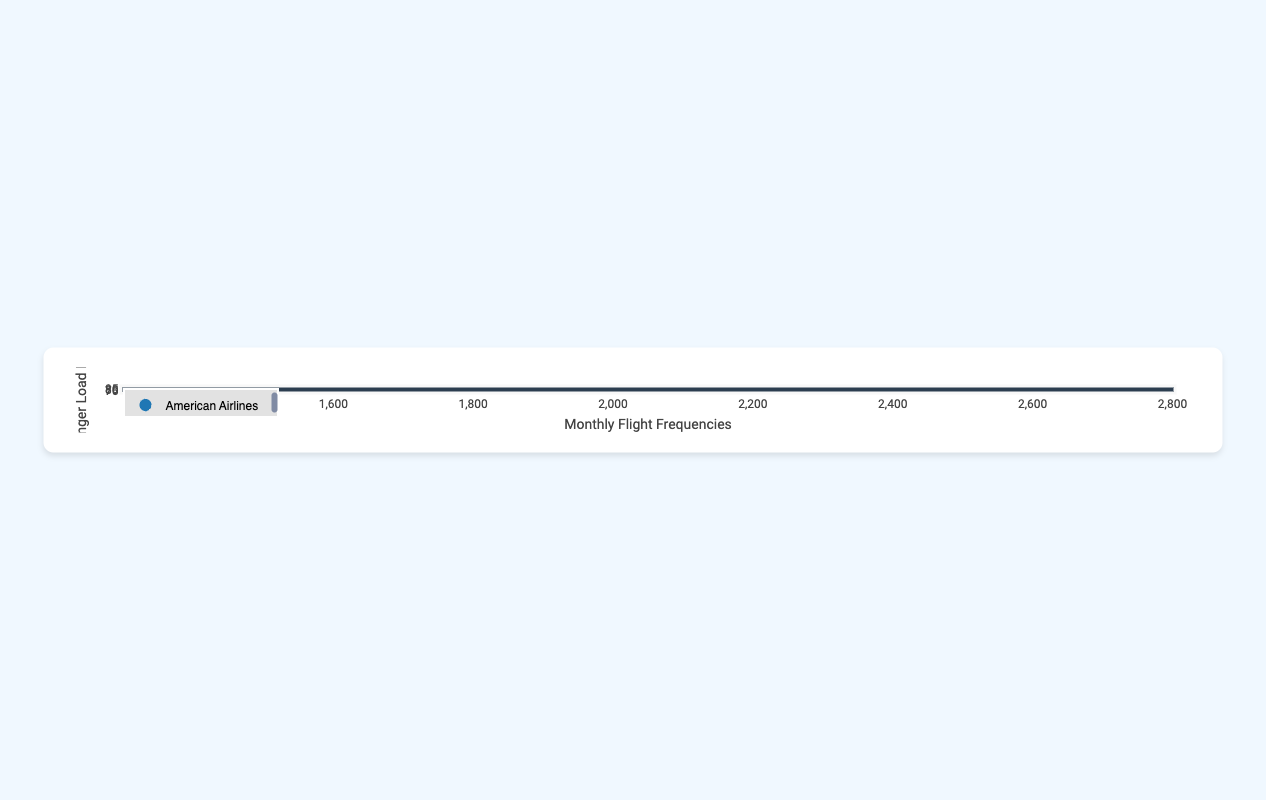What's the highest passenger load factor for January? The highest passenger load factor for January can be found by looking at the y-axis values for all data points labeled "January." It's 85.0% for Southwest Airlines.
Answer: 85.0% What's the total number of flights for Delta Air Lines in both months? Summing up monthly flight frequencies for Delta Air Lines: 2600 (January) + 2400 (February) = 5000 flights.
Answer: 5000 Which airline had the lowest passenger load factor in February? By examining the y-axis values for all points labeled "February," JetBlue Airways had the lowest passenger load factor in February at 74.8%.
Answer: JetBlue Airways Does any airline have a higher passenger load factor in February than in January? By comparing the passenger load factor for each airline in both months, none of the airlines have a higher load factor in February compared to January.
Answer: No Which airline had the most flights in January? Checking the x-axis values for all data points labeled "January," Southwest Airlines had the most flights with 2700.
Answer: Southwest Airlines Compare the passenger load factor between American Airlines and United Airlines in January. Which is higher? By locating their respective values for January, American Airlines has a passenger load factor of 81.5%, while United Airlines has 78.1%. Therefore, American Airlines has a higher load factor.
Answer: American Airlines What's the average passenger load factor for all airlines in February? Considering the values for February: 79.2 (American Airlines) + 80.4 (Delta Air Lines) + 77.9 (United Airlines) + 84.2 (Southwest Airlines) + 74.8 (JetBlue Airways) + 80.1 (Alaska Airlines). Sum these up and divide by the number of airlines, which is 6. (79.2 + 80.4 + 77.9 + 84.2 + 74.8 + 80.1) / 6 = 79.43%.
Answer: 79.43% Which airline's passenger load factor decreased the most from January to February? Calculate the difference for each airline: 
American Airlines: 81.5 - 79.2 = 2.3 
Delta Air Lines: 83.7 - 80.4 = 3.3 
United Airlines: 78.1 - 77.9 = 0.2 
Southwest Airlines: 85.0 - 84.2 = 0.8 
JetBlue Airways: 76.5 - 74.8 = 1.7 
Alaska Airlines: 82.3 - 80.1 = 2.2 
Delta Air Lines decreased the most by 3.3%.
Answer: Delta Air Lines What's the range of the monthly flight frequencies in the plot? The range can be determined by subtracting the minimum value on the x-axis from the maximum value. The maximum is 2700 (Southwest Airlines in January), and the minimum is 1400 (JetBlue Airways in February). Hence, 2700 - 1400 = 1300.
Answer: 1300 Which month shows a higher overall passenger load factor, January or February? Sum the passenger load factors for January: 81.5 + 83.7 + 78.1 + 85.0 + 76.5 + 82.3 = 487.1. Divide by 6: 487.1 / 6 = 81.18%. For February: 79.2 + 80.4 + 77.9 + 84.2 + 74.8 + 80.1 = 476.6. Divide by 6: 476.6 / 6 = 79.43%. January has a higher overall passenger load factor.
Answer: January 